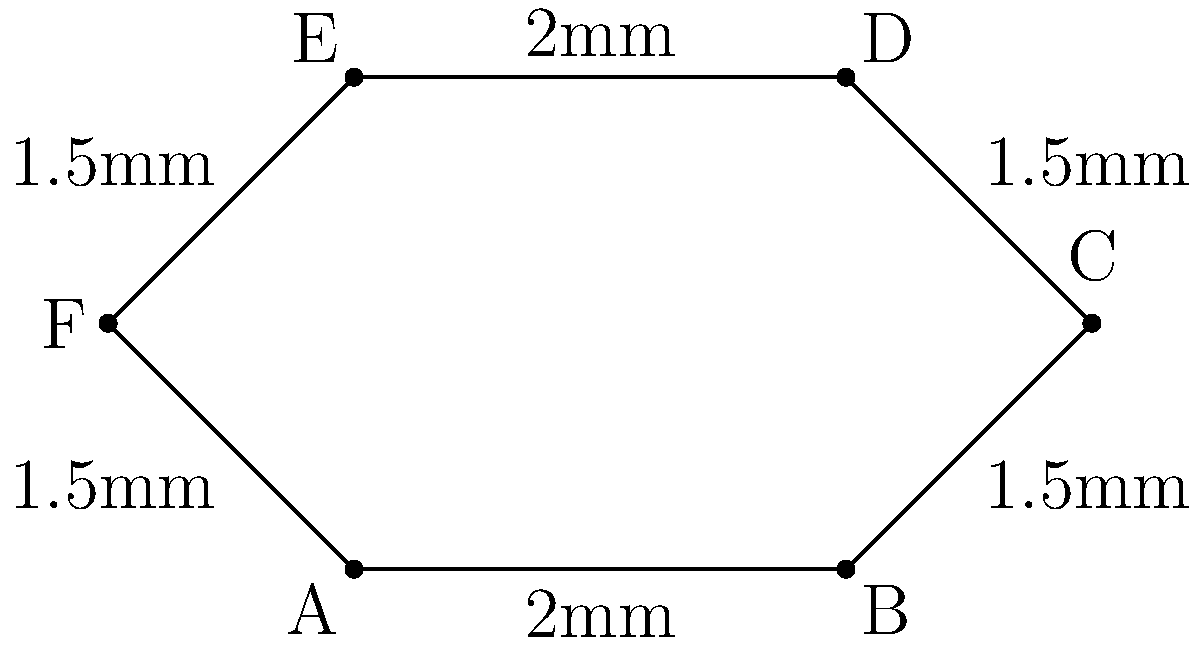You're designing a custom hexagonal microcontroller chip. The chip has alternating side lengths of 2mm and 1.5mm, as shown in the diagram. What is the perimeter of this hexagonal chip in millimeters? To find the perimeter of the hexagonal microcontroller chip, we need to sum up the lengths of all sides. Let's break it down step-by-step:

1. Identify the side lengths:
   - Sides AB and DE are 2mm each
   - Sides BC, CD, EF, and FA are 1.5mm each

2. Sum up all the side lengths:
   $$ \text{Perimeter} = AB + BC + CD + DE + EF + FA $$
   $$ = 2mm + 1.5mm + 1.5mm + 2mm + 1.5mm + 1.5mm $$

3. Calculate the total:
   $$ = 2(2mm) + 4(1.5mm) $$
   $$ = 4mm + 6mm $$
   $$ = 10mm $$

Therefore, the perimeter of the hexagonal microcontroller chip is 10mm.
Answer: 10mm 